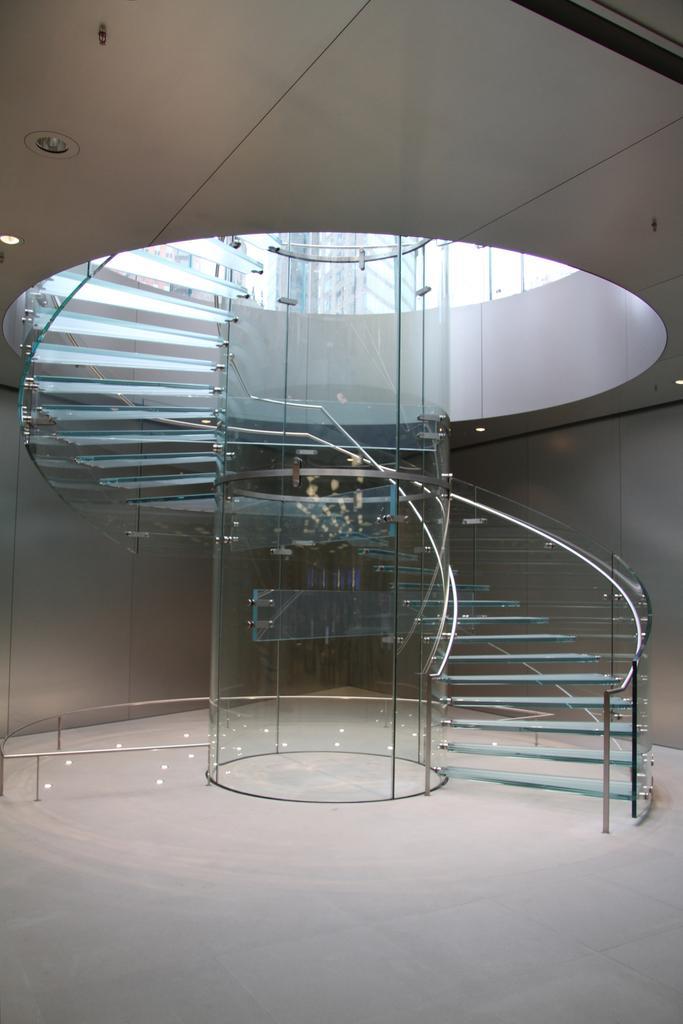Can you describe this image briefly? In this picture I can see there is a stair case which is made of glass and there is a railing around it and there are lights attached to the ceiling. 